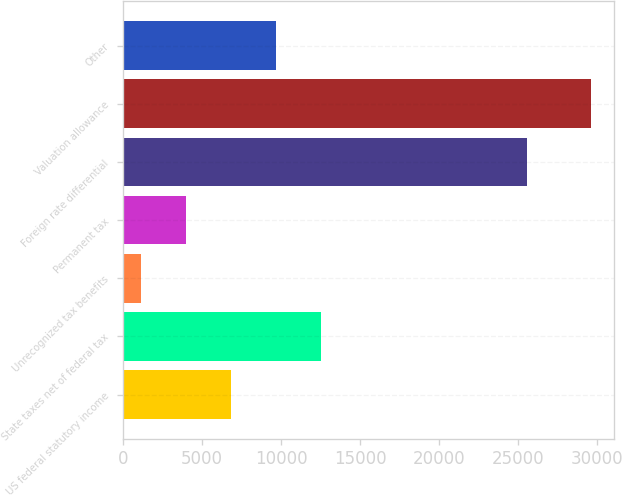<chart> <loc_0><loc_0><loc_500><loc_500><bar_chart><fcel>US federal statutory income<fcel>State taxes net of federal tax<fcel>Unrecognized tax benefits<fcel>Permanent tax<fcel>Foreign rate differential<fcel>Valuation allowance<fcel>Other<nl><fcel>6855<fcel>12532<fcel>1178<fcel>4016.5<fcel>25563<fcel>29563<fcel>9693.5<nl></chart> 